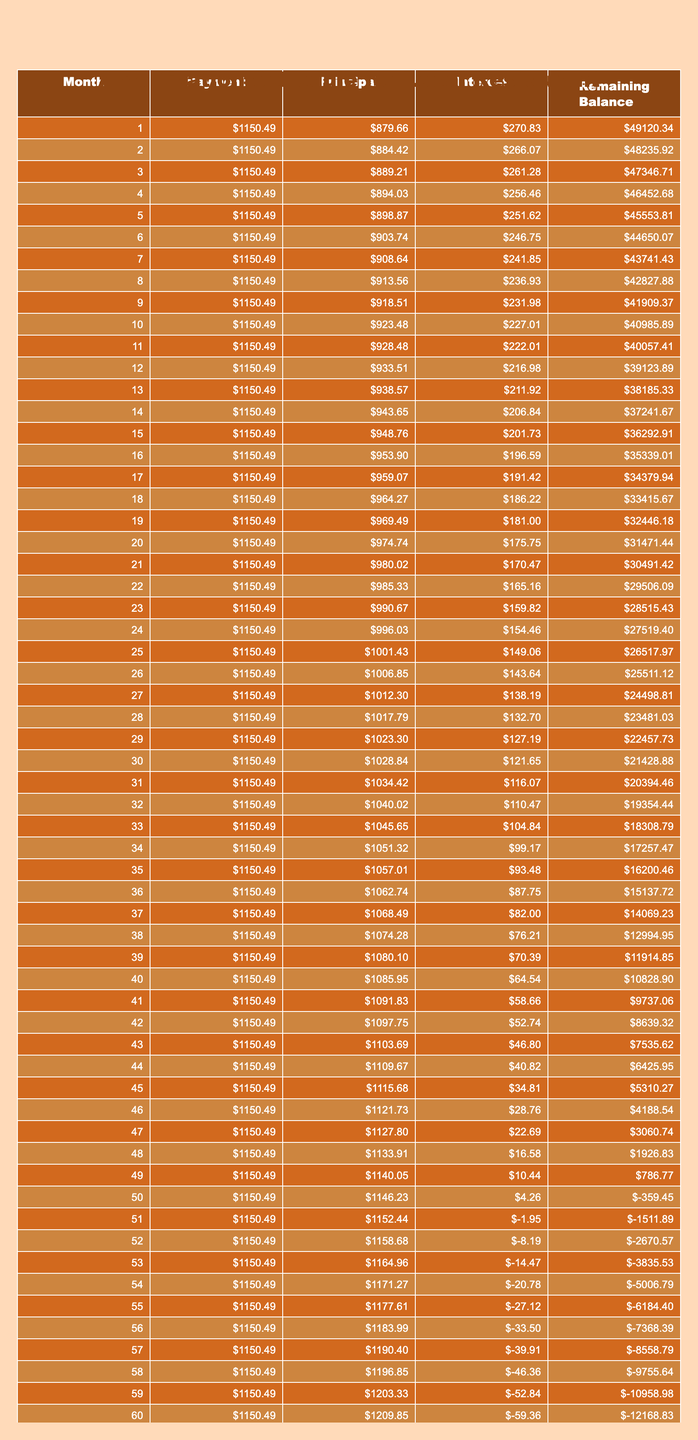What is the total payment made over the loan term? The total payment made over the loan term is directly provided in the table under the column "Total Payment." It shows that the total payment will amount to $69,029.40.
Answer: $69,029.40 How much interest will be paid in total by the end of the loan? The total interest paid by the end of the loan is stated in the "Total Interest" column of the table, which indicates that the total interest will be $19,229.40.
Answer: $19,229.40 What is the amount of the principal paid in the 10th month? To find the principal paid in the 10th month, refer to the respective row in the table and look for the value under the "Principal" column for month 10. It shows that the principal amount paid in the 10th month is $872.34.
Answer: $872.34 Is the monthly payment sufficient to cover the interest in the first month? In the first month, the monthly payment is $1,150.49, and the interest for the first month is calculated as the loan amount multiplied by the monthly interest rate (6.5% annual = 0.00541667 monthly) = $270.83. Since $1,150.49 is greater than $270.83, the monthly payment is sufficient to cover the interest.
Answer: Yes What will the remaining balance be after the 12th monthly payment? To find the remaining balance after the 12th payment, check the table for the value under the "Remaining Balance" column at month 12, which is $46,124.33. This shows the remaining balance after the 12th payment.
Answer: $46,124.33 What is the average principal payment over the entire loan? To calculate the average principal payment over the loan, add up the principal payments from each month and divide by the number of payments (60 months). The total principal paid is the loan amount of $50,000, so the average is $50,000 / 60 = $833.33.
Answer: $833.33 How much will be paid toward principal in the last month? For the last month, check the table for the principal payment listed for month 60 under the "Principal" column. It shows that the amount paid toward principal in the last month is $1,150.49.
Answer: $1,150.49 Does the loan term exceed 5 years? The loan term is specified as 60 months in the table, which equals 5 years (60 months / 12 months per year). Therefore, the statement that the loan term exceeds 5 years is not true.
Answer: No What is the difference between the total payment and the total interest? The difference between total payment and total interest can be calculated by subtracting the total interest ($19,229.40) from the total payment ($69,029.40): $69,029.40 - $19,229.40 = $49,800.00. Hence, this value represents the total principal repaid.
Answer: $49,800.00 